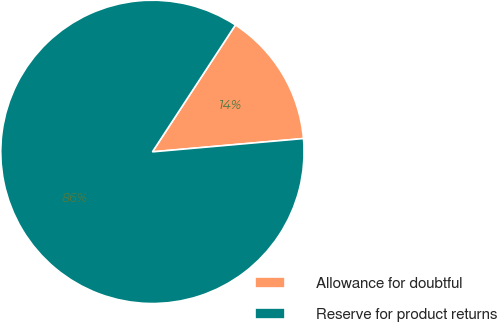Convert chart. <chart><loc_0><loc_0><loc_500><loc_500><pie_chart><fcel>Allowance for doubtful<fcel>Reserve for product returns<nl><fcel>14.38%<fcel>85.62%<nl></chart> 